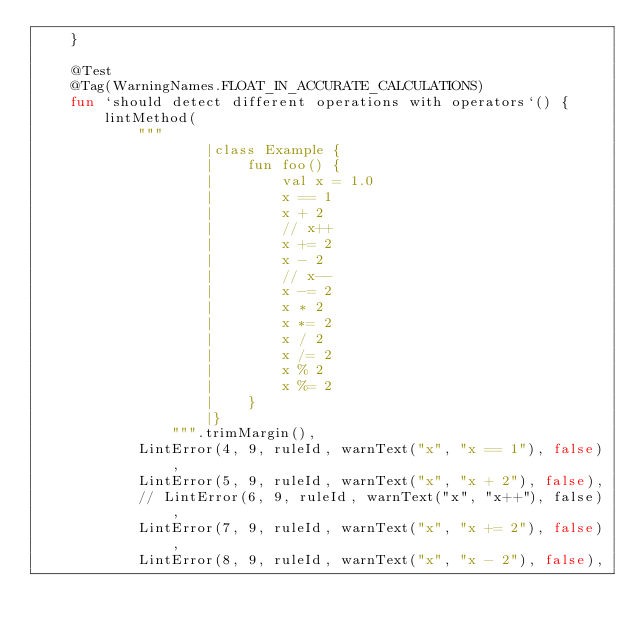Convert code to text. <code><loc_0><loc_0><loc_500><loc_500><_Kotlin_>    }

    @Test
    @Tag(WarningNames.FLOAT_IN_ACCURATE_CALCULATIONS)
    fun `should detect different operations with operators`() {
        lintMethod(
            """
                    |class Example {
                    |    fun foo() {
                    |        val x = 1.0
                    |        x == 1
                    |        x + 2
                    |        // x++
                    |        x += 2
                    |        x - 2
                    |        // x--
                    |        x -= 2
                    |        x * 2
                    |        x *= 2
                    |        x / 2
                    |        x /= 2
                    |        x % 2
                    |        x %= 2
                    |    }
                    |}
                """.trimMargin(),
            LintError(4, 9, ruleId, warnText("x", "x == 1"), false),
            LintError(5, 9, ruleId, warnText("x", "x + 2"), false),
            // LintError(6, 9, ruleId, warnText("x", "x++"), false),
            LintError(7, 9, ruleId, warnText("x", "x += 2"), false),
            LintError(8, 9, ruleId, warnText("x", "x - 2"), false),</code> 